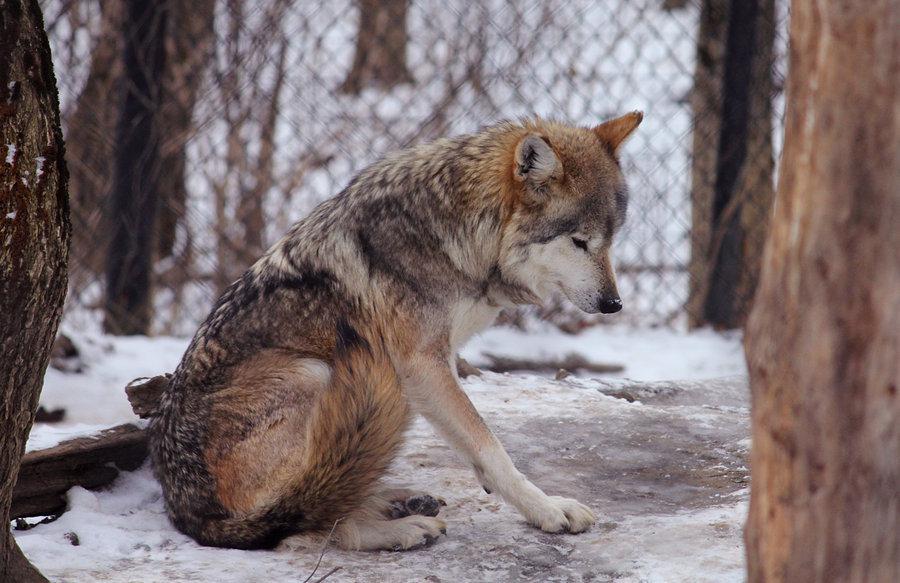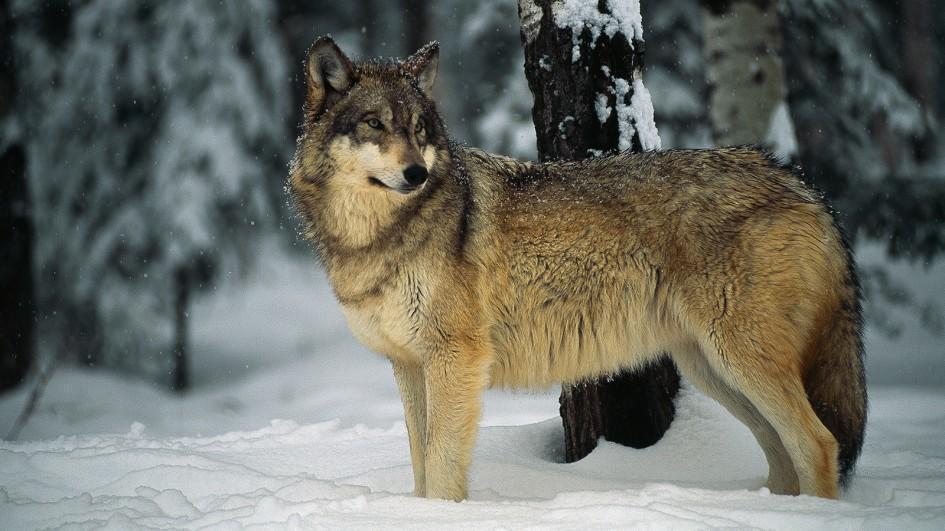The first image is the image on the left, the second image is the image on the right. For the images shown, is this caption "The left-hand image shows a wolf that is not standing on all fours." true? Answer yes or no. Yes. 